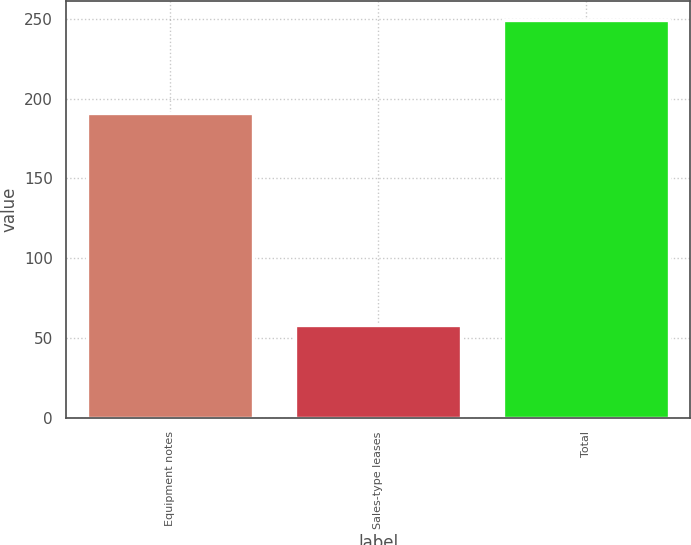Convert chart. <chart><loc_0><loc_0><loc_500><loc_500><bar_chart><fcel>Equipment notes<fcel>Sales-type leases<fcel>Total<nl><fcel>191<fcel>58<fcel>249<nl></chart> 